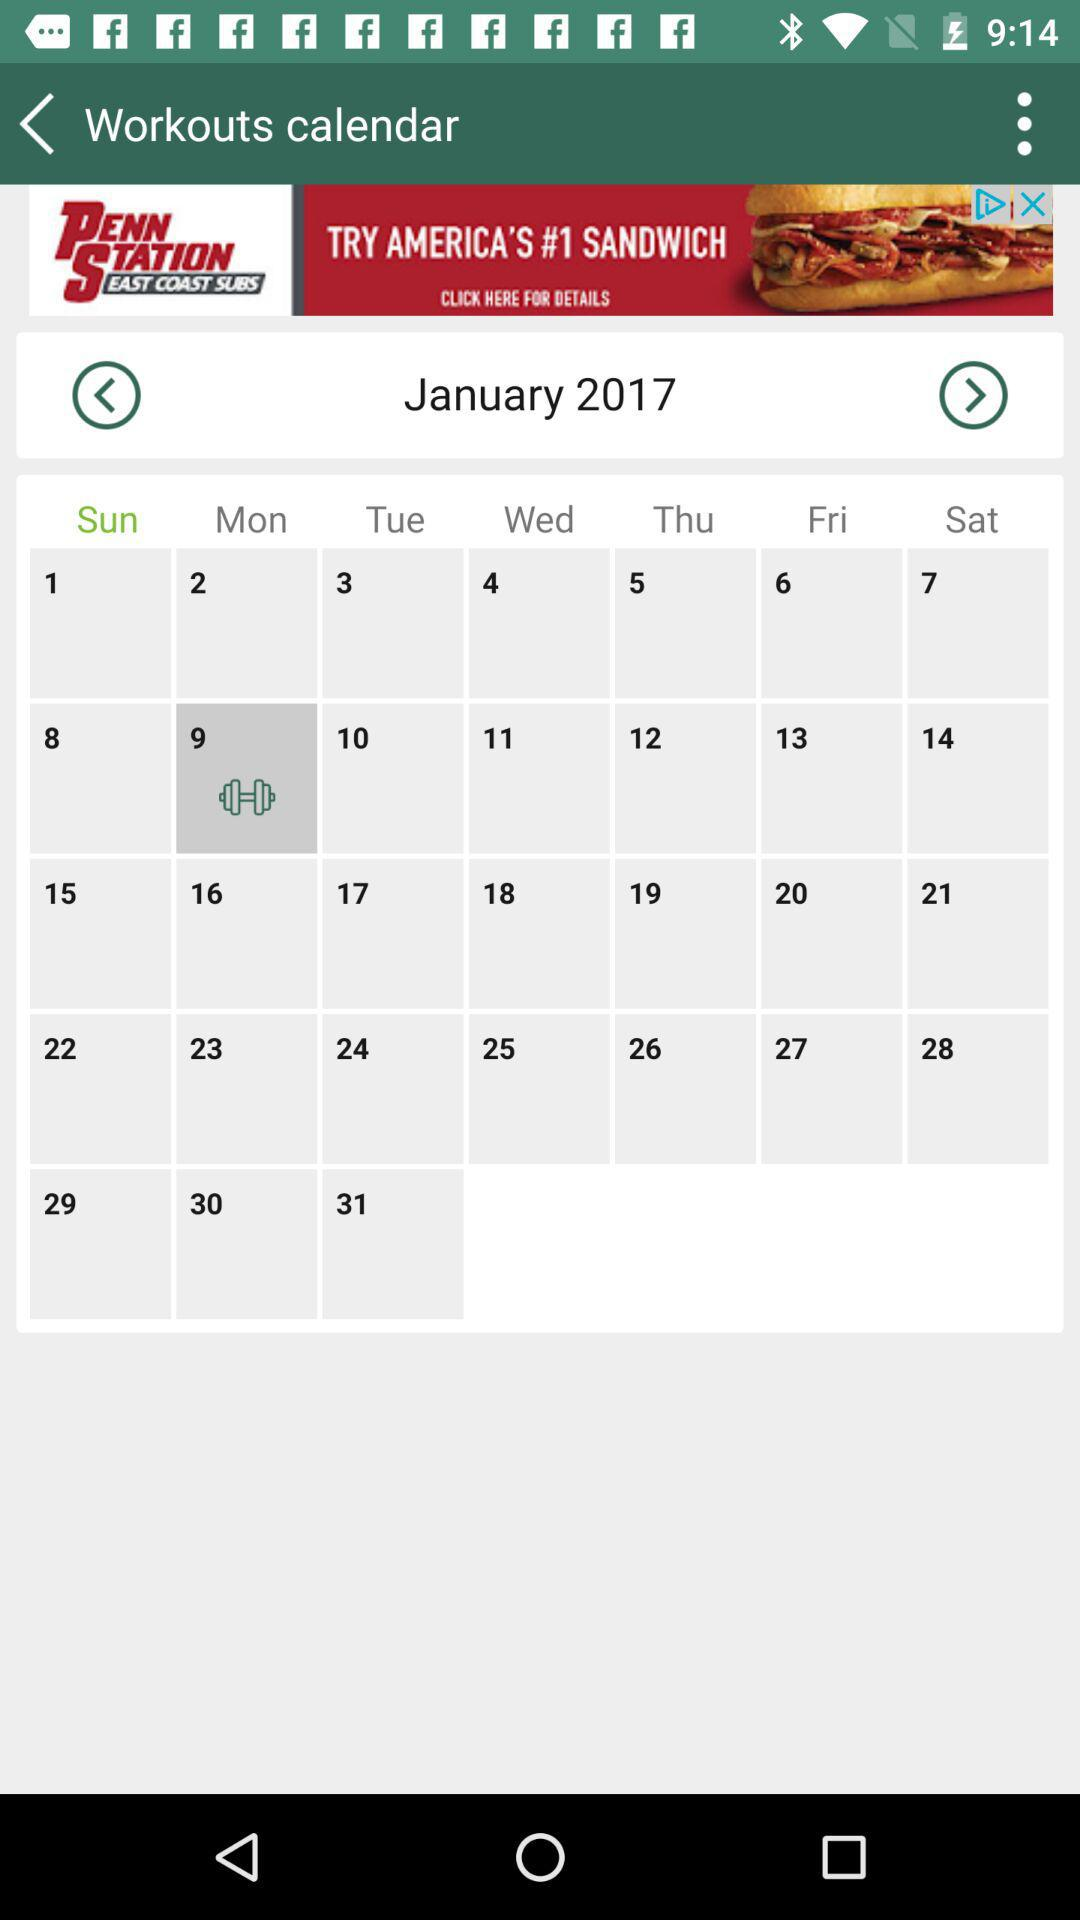Which month of the calendar is shown on the screen? The month shown on the screen is January. 